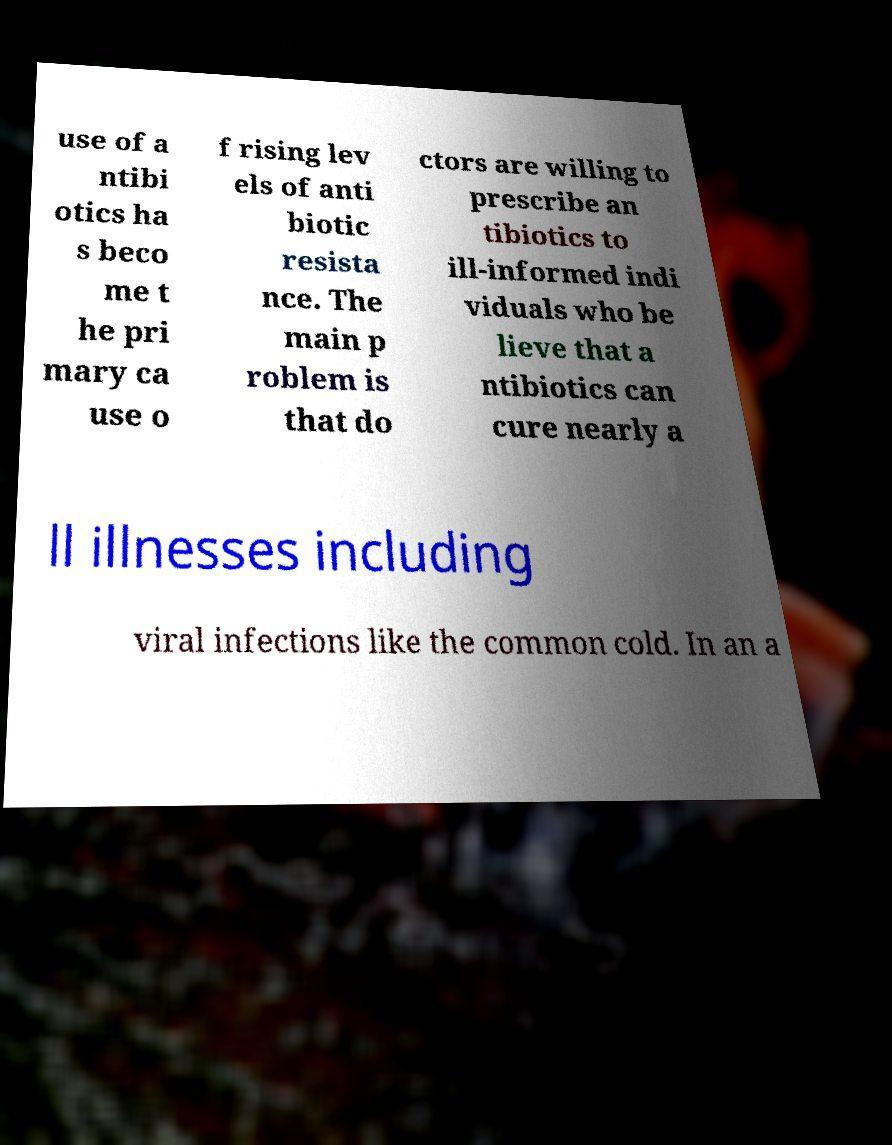Can you accurately transcribe the text from the provided image for me? use of a ntibi otics ha s beco me t he pri mary ca use o f rising lev els of anti biotic resista nce. The main p roblem is that do ctors are willing to prescribe an tibiotics to ill-informed indi viduals who be lieve that a ntibiotics can cure nearly a ll illnesses including viral infections like the common cold. In an a 